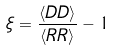Convert formula to latex. <formula><loc_0><loc_0><loc_500><loc_500>\xi = \frac { \langle D D \rangle } { \langle R R \rangle } - 1</formula> 